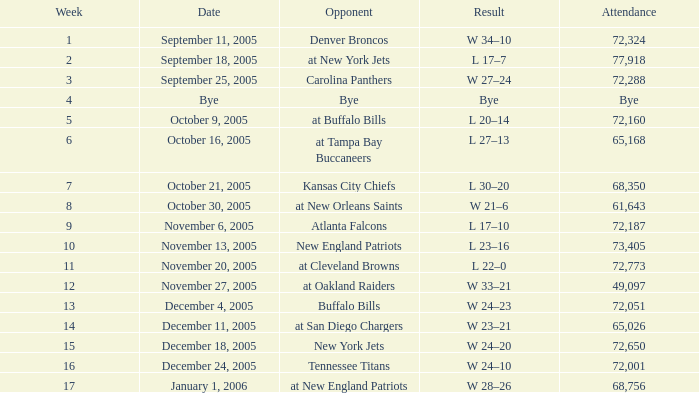In which week was the attendance recorded as 49,097? 12.0. 